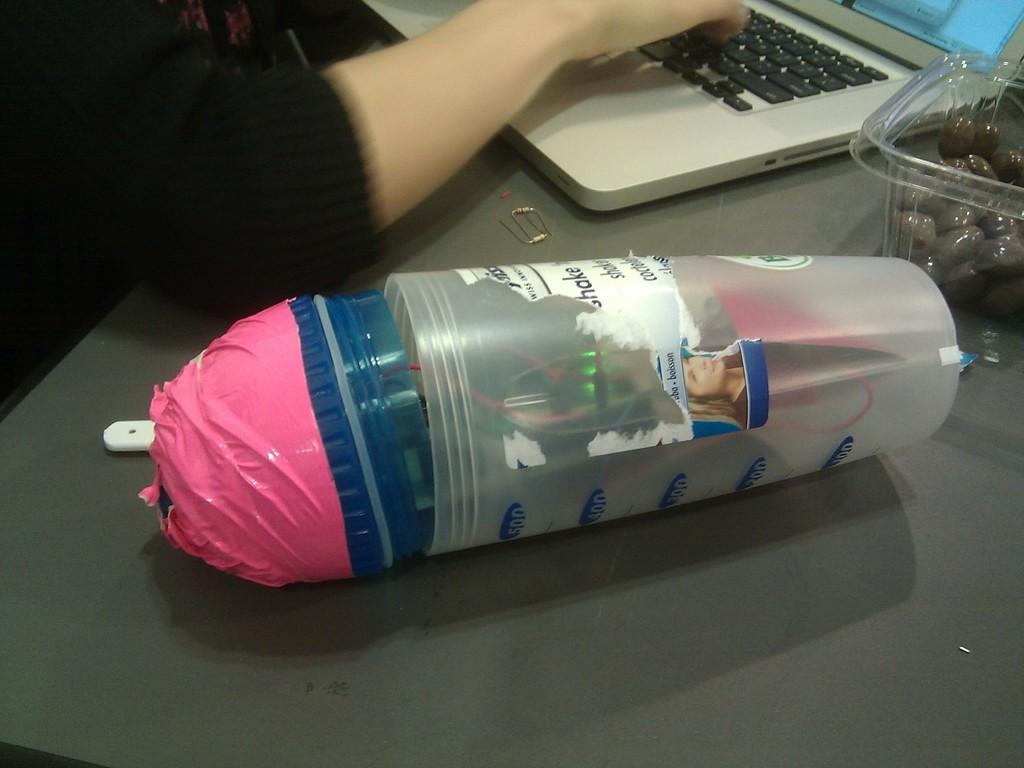Provide a one-sentence caption for the provided image. A clutter filled measuring cup with the top number saying 500. 